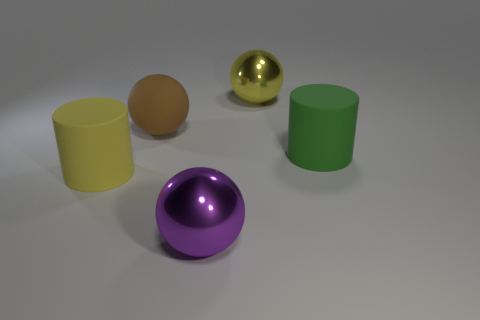The large matte cylinder that is to the right of the large matte cylinder that is in front of the green rubber cylinder behind the yellow rubber cylinder is what color?
Your answer should be compact. Green. There is a ball that is the same material as the big green thing; what is its color?
Give a very brief answer. Brown. How many other big yellow cylinders are the same material as the large yellow cylinder?
Make the answer very short. 0. The other cylinder that is the same size as the yellow rubber cylinder is what color?
Your answer should be compact. Green. How many green matte things are to the left of the green cylinder?
Your answer should be very brief. 0. Are any purple balls visible?
Make the answer very short. Yes. How many other things are the same size as the brown matte thing?
Ensure brevity in your answer.  4. Are there any other things of the same color as the large rubber ball?
Make the answer very short. No. Is the large cylinder on the right side of the large yellow sphere made of the same material as the large brown sphere?
Your response must be concise. Yes. What number of objects are both behind the big yellow rubber thing and to the left of the large purple thing?
Your answer should be compact. 1. 